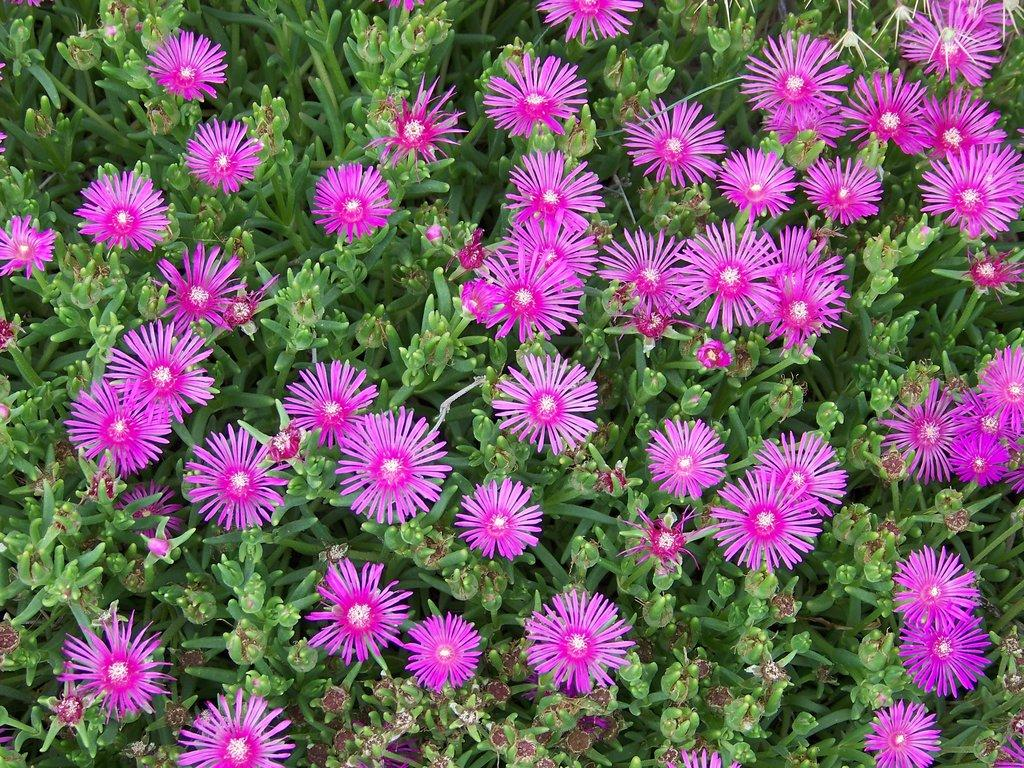What type of living organisms can be seen in the image? Plants can be seen in the image. What color are the flowers on the plants in the image? There are pink flowers in the image. What type of vegetable is being rolled up in the image? There is no vegetable or rolling action present in the image; it features plants with pink flowers. What is the value of the item being displayed in the image? There is no item being displayed in the image that has a value associated with it. 